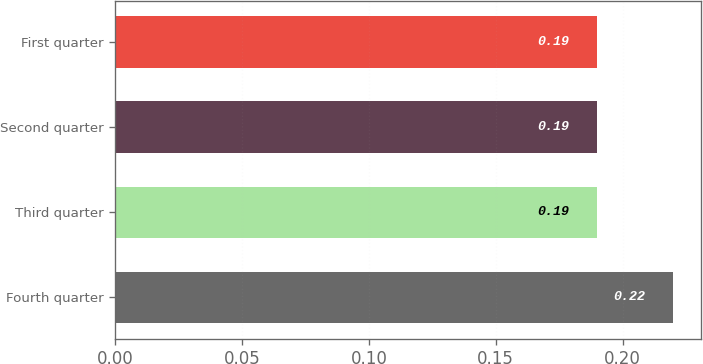Convert chart to OTSL. <chart><loc_0><loc_0><loc_500><loc_500><bar_chart><fcel>Fourth quarter<fcel>Third quarter<fcel>Second quarter<fcel>First quarter<nl><fcel>0.22<fcel>0.19<fcel>0.19<fcel>0.19<nl></chart> 